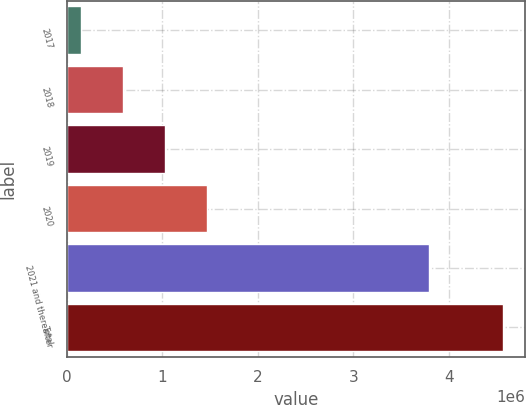<chart> <loc_0><loc_0><loc_500><loc_500><bar_chart><fcel>2017<fcel>2018<fcel>2019<fcel>2020<fcel>2021 and thereafter<fcel>Total<nl><fcel>145938<fcel>588044<fcel>1.03015e+06<fcel>1.47226e+06<fcel>3.78936e+06<fcel>4.567e+06<nl></chart> 